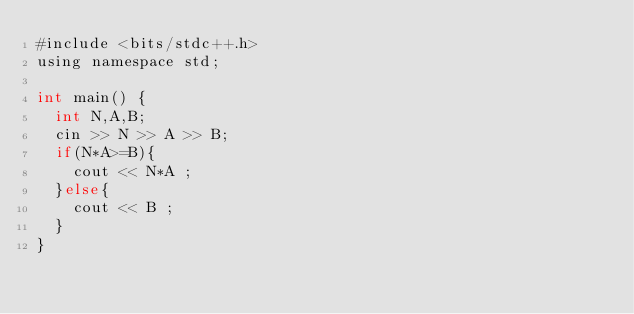Convert code to text. <code><loc_0><loc_0><loc_500><loc_500><_Java_>#include <bits/stdc++.h>
using namespace std;

int main() {
  int N,A,B;
  cin >> N >> A >> B;
  if(N*A>=B){
    cout << N*A ;
  }else{
    cout << B ;
  }
}
</code> 